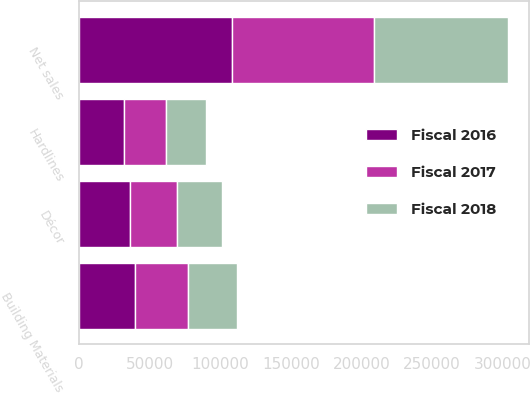<chart> <loc_0><loc_0><loc_500><loc_500><stacked_bar_chart><ecel><fcel>Building Materials<fcel>Décor<fcel>Hardlines<fcel>Net sales<nl><fcel>Fiscal 2016<fcel>39967<fcel>36238<fcel>31998<fcel>108203<nl><fcel>Fiscal 2017<fcel>37331<fcel>33583<fcel>29990<fcel>100904<nl><fcel>Fiscal 2018<fcel>34768<fcel>31599<fcel>28228<fcel>94595<nl></chart> 